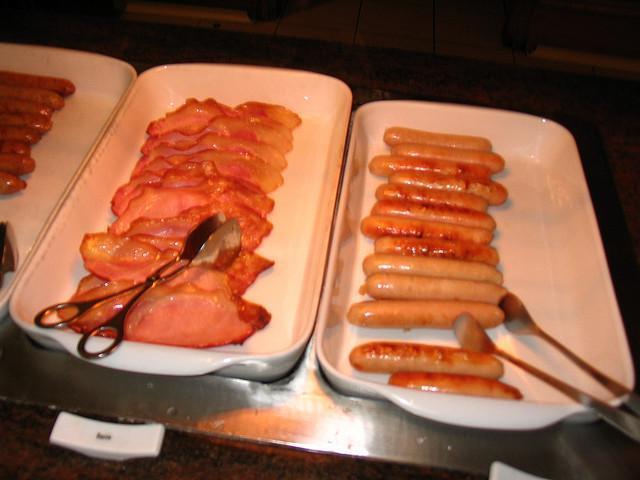How many spoons are in the photo?
Give a very brief answer. 2. How many bowls are in the picture?
Give a very brief answer. 3. How many hot dogs can you see?
Give a very brief answer. 11. How many white horse are in the picture?
Give a very brief answer. 0. 